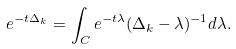Convert formula to latex. <formula><loc_0><loc_0><loc_500><loc_500>e ^ { - t \Delta _ { k } } = \int _ { C } e ^ { - t \lambda } ( \Delta _ { k } - \lambda ) ^ { - 1 } d \lambda .</formula> 